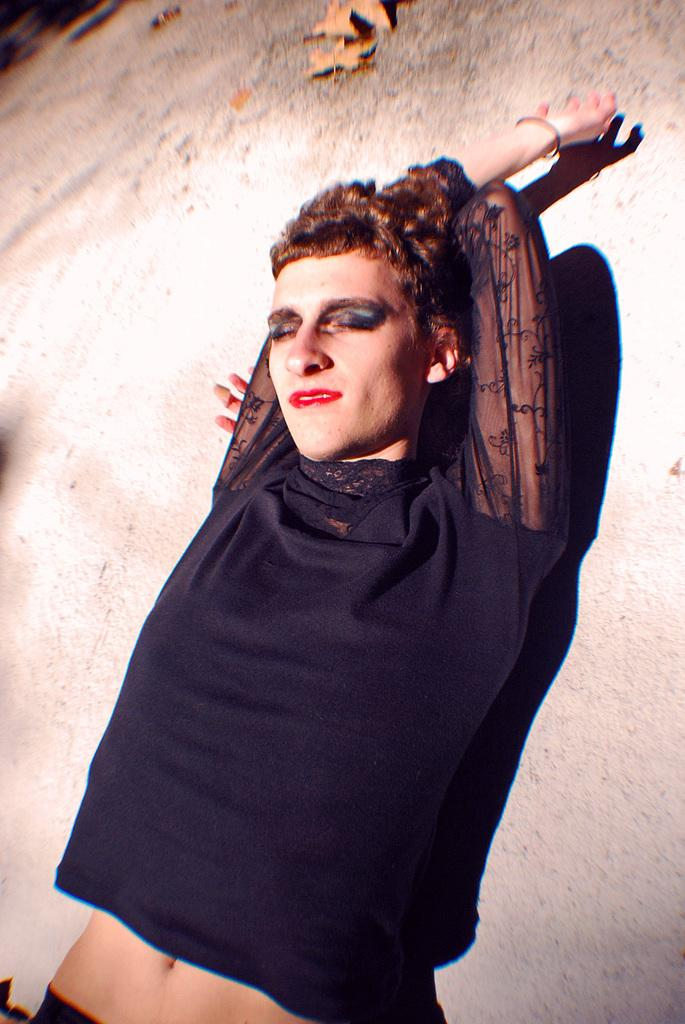What is the position of the person in the image? There is a person lying on the floor in the image. What can be seen on the floor besides the person? There are leaves on the floor. What color is the top worn by the person in the image? The person is wearing a black top. Can you see a needle being used by the person in the image? There is no needle present in the image. What sense is being utilized by the person in the image? The image does not provide information about which sense the person is using. 